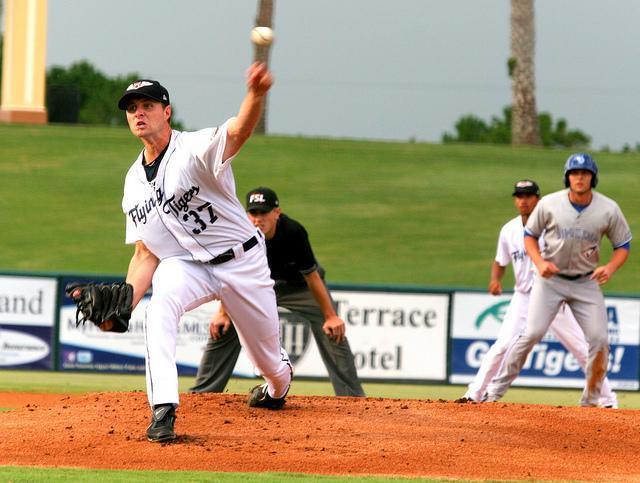How many people are there?
Give a very brief answer. 4. 